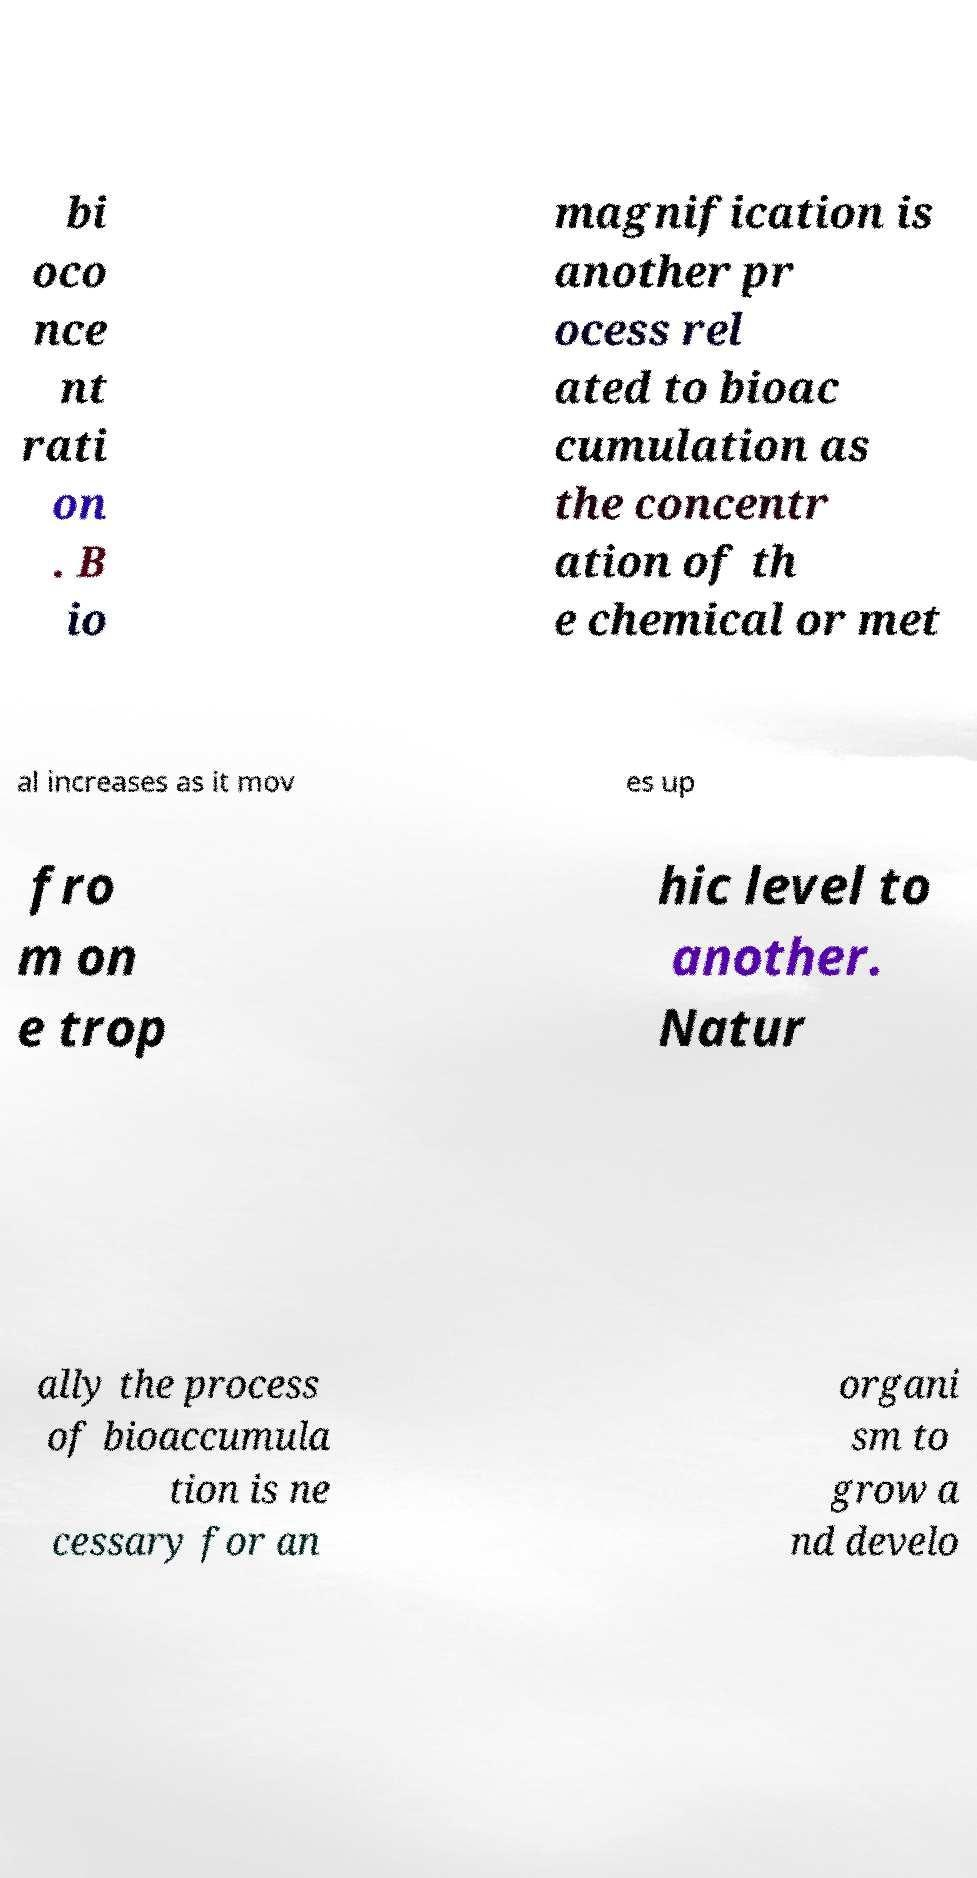I need the written content from this picture converted into text. Can you do that? bi oco nce nt rati on . B io magnification is another pr ocess rel ated to bioac cumulation as the concentr ation of th e chemical or met al increases as it mov es up fro m on e trop hic level to another. Natur ally the process of bioaccumula tion is ne cessary for an organi sm to grow a nd develo 